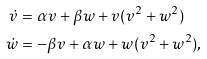Convert formula to latex. <formula><loc_0><loc_0><loc_500><loc_500>\dot { v } & = \alpha v + \beta w + v ( v ^ { 2 } + w ^ { 2 } ) \\ \dot { w } & = - \beta v + \alpha w + w ( v ^ { 2 } + w ^ { 2 } ) , \\</formula> 